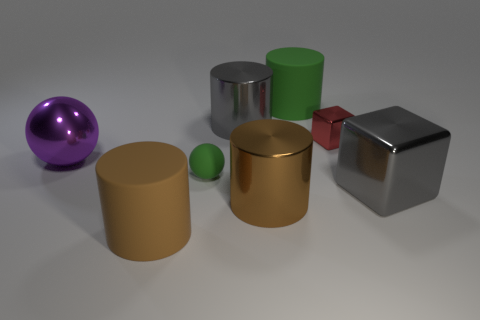Add 2 green objects. How many objects exist? 10 Subtract all spheres. How many objects are left? 6 Subtract all blue metal things. Subtract all green matte spheres. How many objects are left? 7 Add 1 small red metallic objects. How many small red metallic objects are left? 2 Add 6 green matte balls. How many green matte balls exist? 7 Subtract 0 cyan cylinders. How many objects are left? 8 